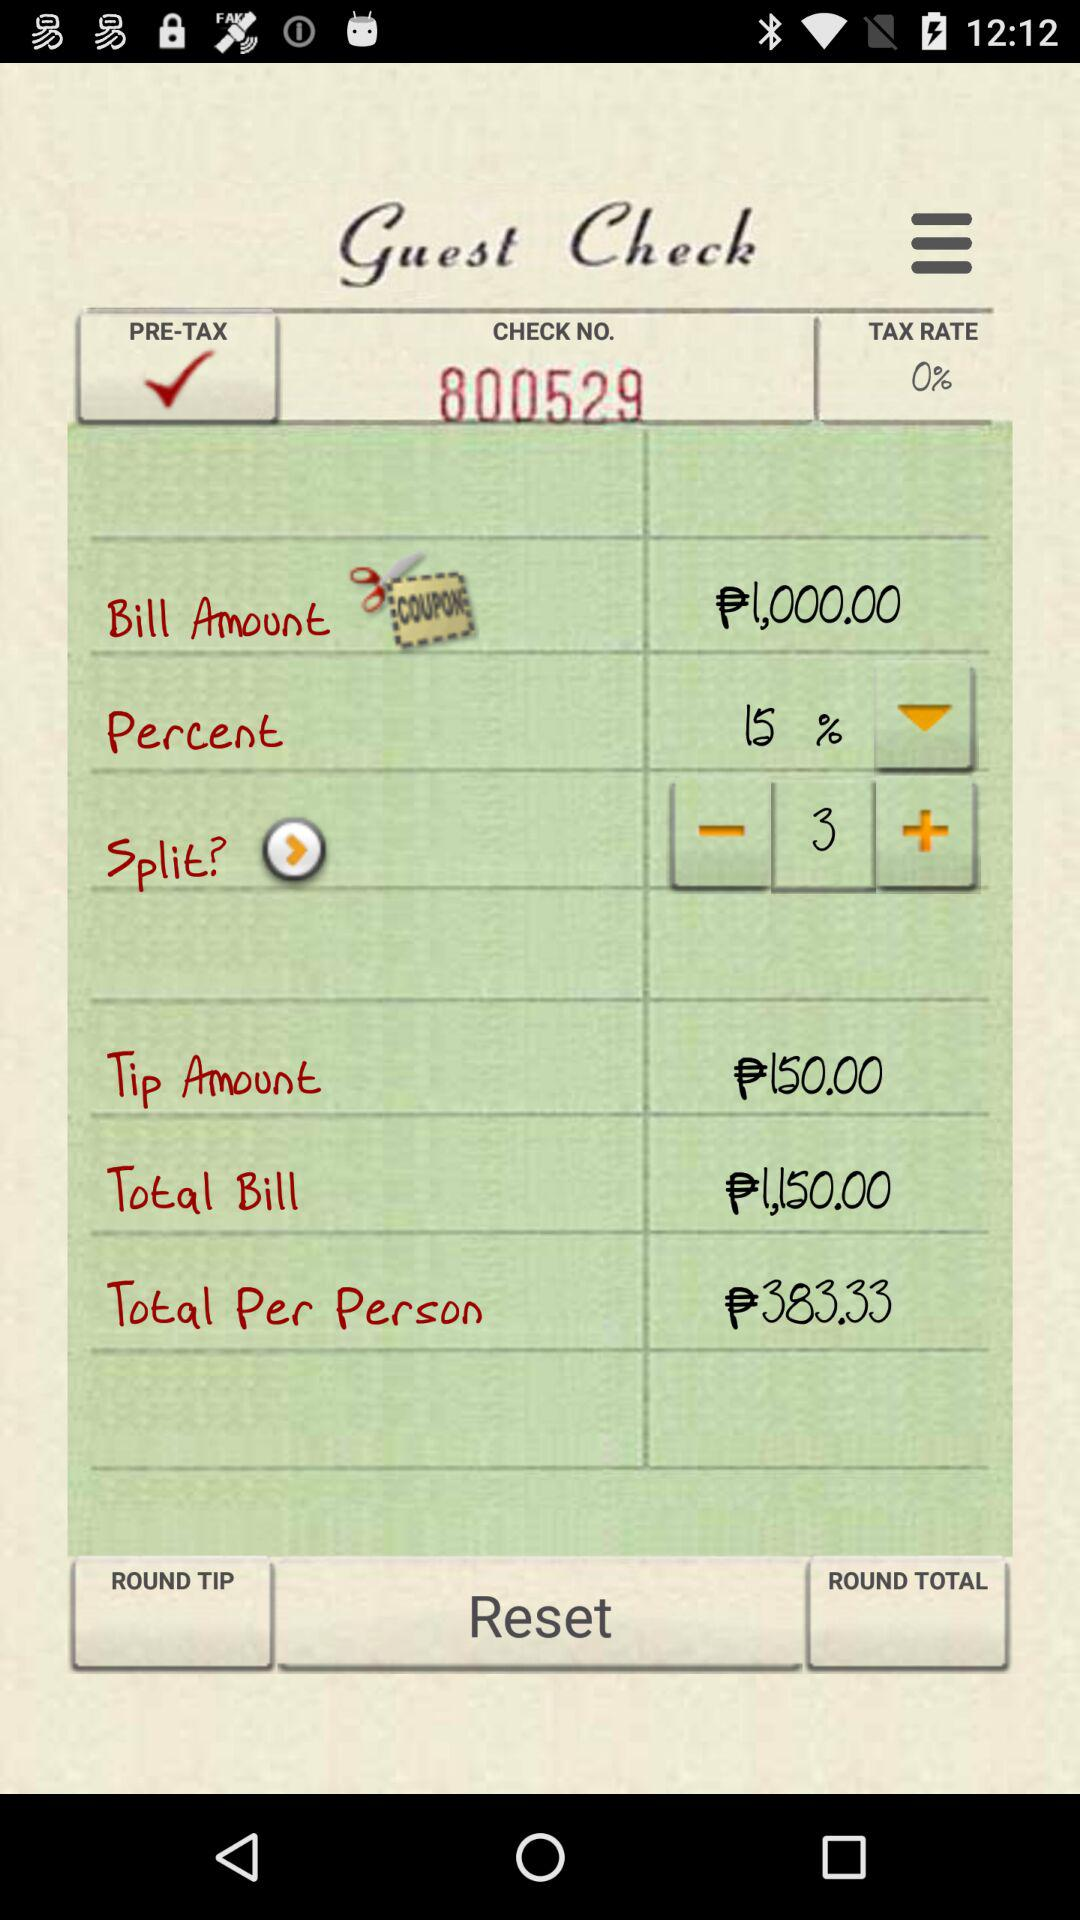What is the bill amount? The bill amount is ₱1,000. 